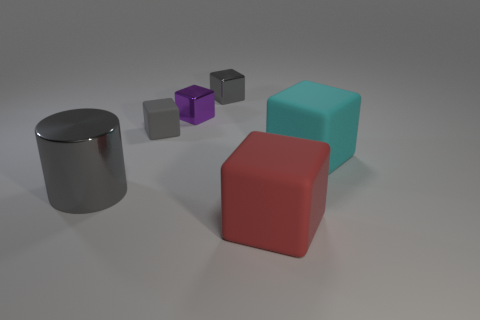What could be the purpose of these objects? The objects could serve various purposes. They might be educational tools used to teach geometry or 3D modeling primitives. Alternatively, they could be elements of a design or decor, given their simplistic yet aesthetically pleasing forms and colors, suitable for modern styles. 